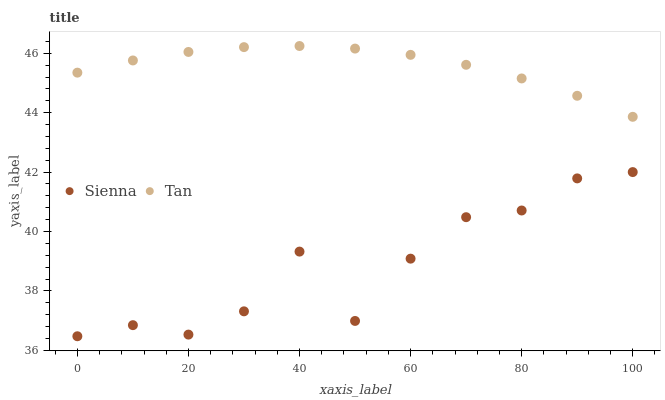Does Sienna have the minimum area under the curve?
Answer yes or no. Yes. Does Tan have the maximum area under the curve?
Answer yes or no. Yes. Does Tan have the minimum area under the curve?
Answer yes or no. No. Is Tan the smoothest?
Answer yes or no. Yes. Is Sienna the roughest?
Answer yes or no. Yes. Is Tan the roughest?
Answer yes or no. No. Does Sienna have the lowest value?
Answer yes or no. Yes. Does Tan have the lowest value?
Answer yes or no. No. Does Tan have the highest value?
Answer yes or no. Yes. Is Sienna less than Tan?
Answer yes or no. Yes. Is Tan greater than Sienna?
Answer yes or no. Yes. Does Sienna intersect Tan?
Answer yes or no. No. 